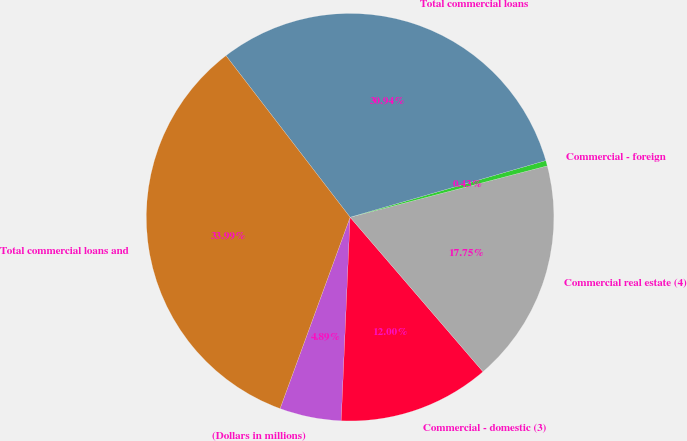Convert chart. <chart><loc_0><loc_0><loc_500><loc_500><pie_chart><fcel>(Dollars in millions)<fcel>Commercial - domestic (3)<fcel>Commercial real estate (4)<fcel>Commercial - foreign<fcel>Total commercial loans<fcel>Total commercial loans and<nl><fcel>4.89%<fcel>12.0%<fcel>17.75%<fcel>0.43%<fcel>30.94%<fcel>33.99%<nl></chart> 